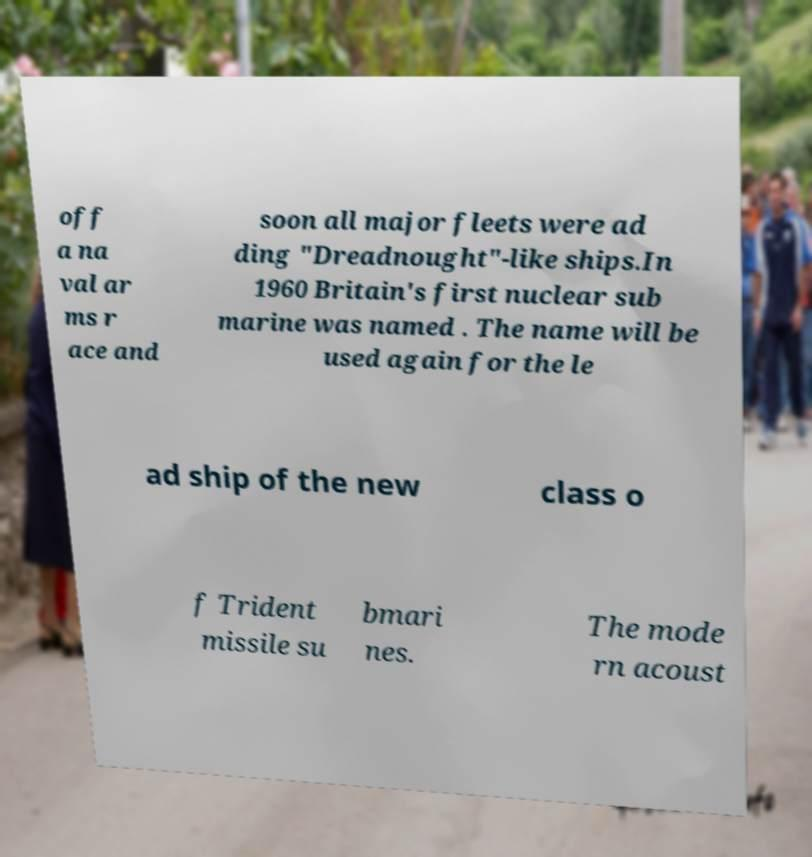Please read and relay the text visible in this image. What does it say? off a na val ar ms r ace and soon all major fleets were ad ding "Dreadnought"-like ships.In 1960 Britain's first nuclear sub marine was named . The name will be used again for the le ad ship of the new class o f Trident missile su bmari nes. The mode rn acoust 